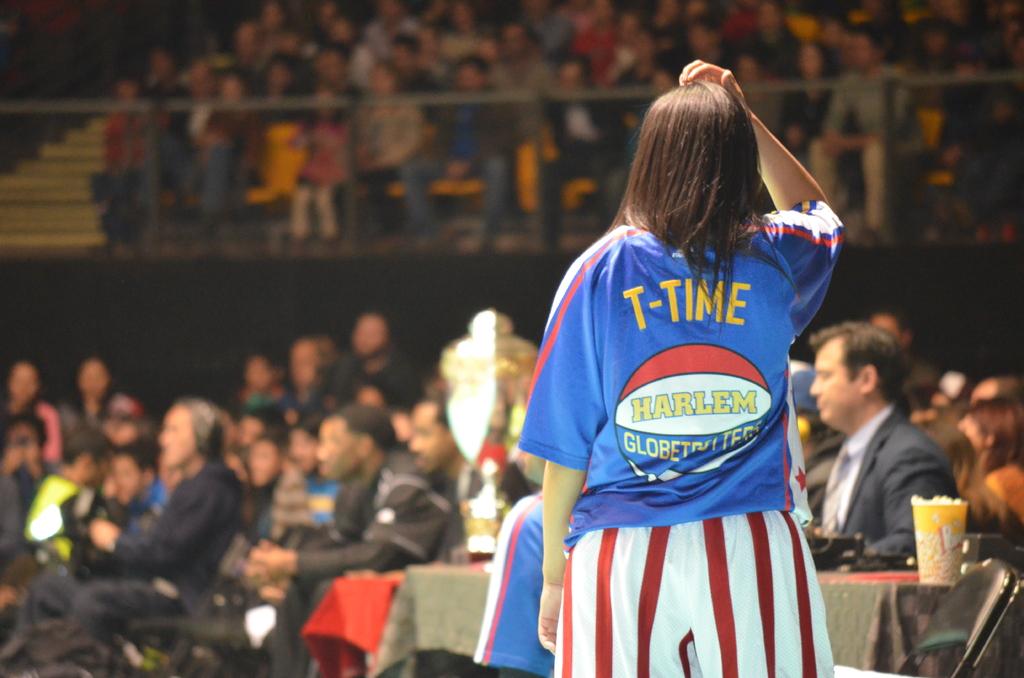What time is it?
Provide a short and direct response. T-time. Which team is this shirt for?
Offer a terse response. Harlem globetrotters. 